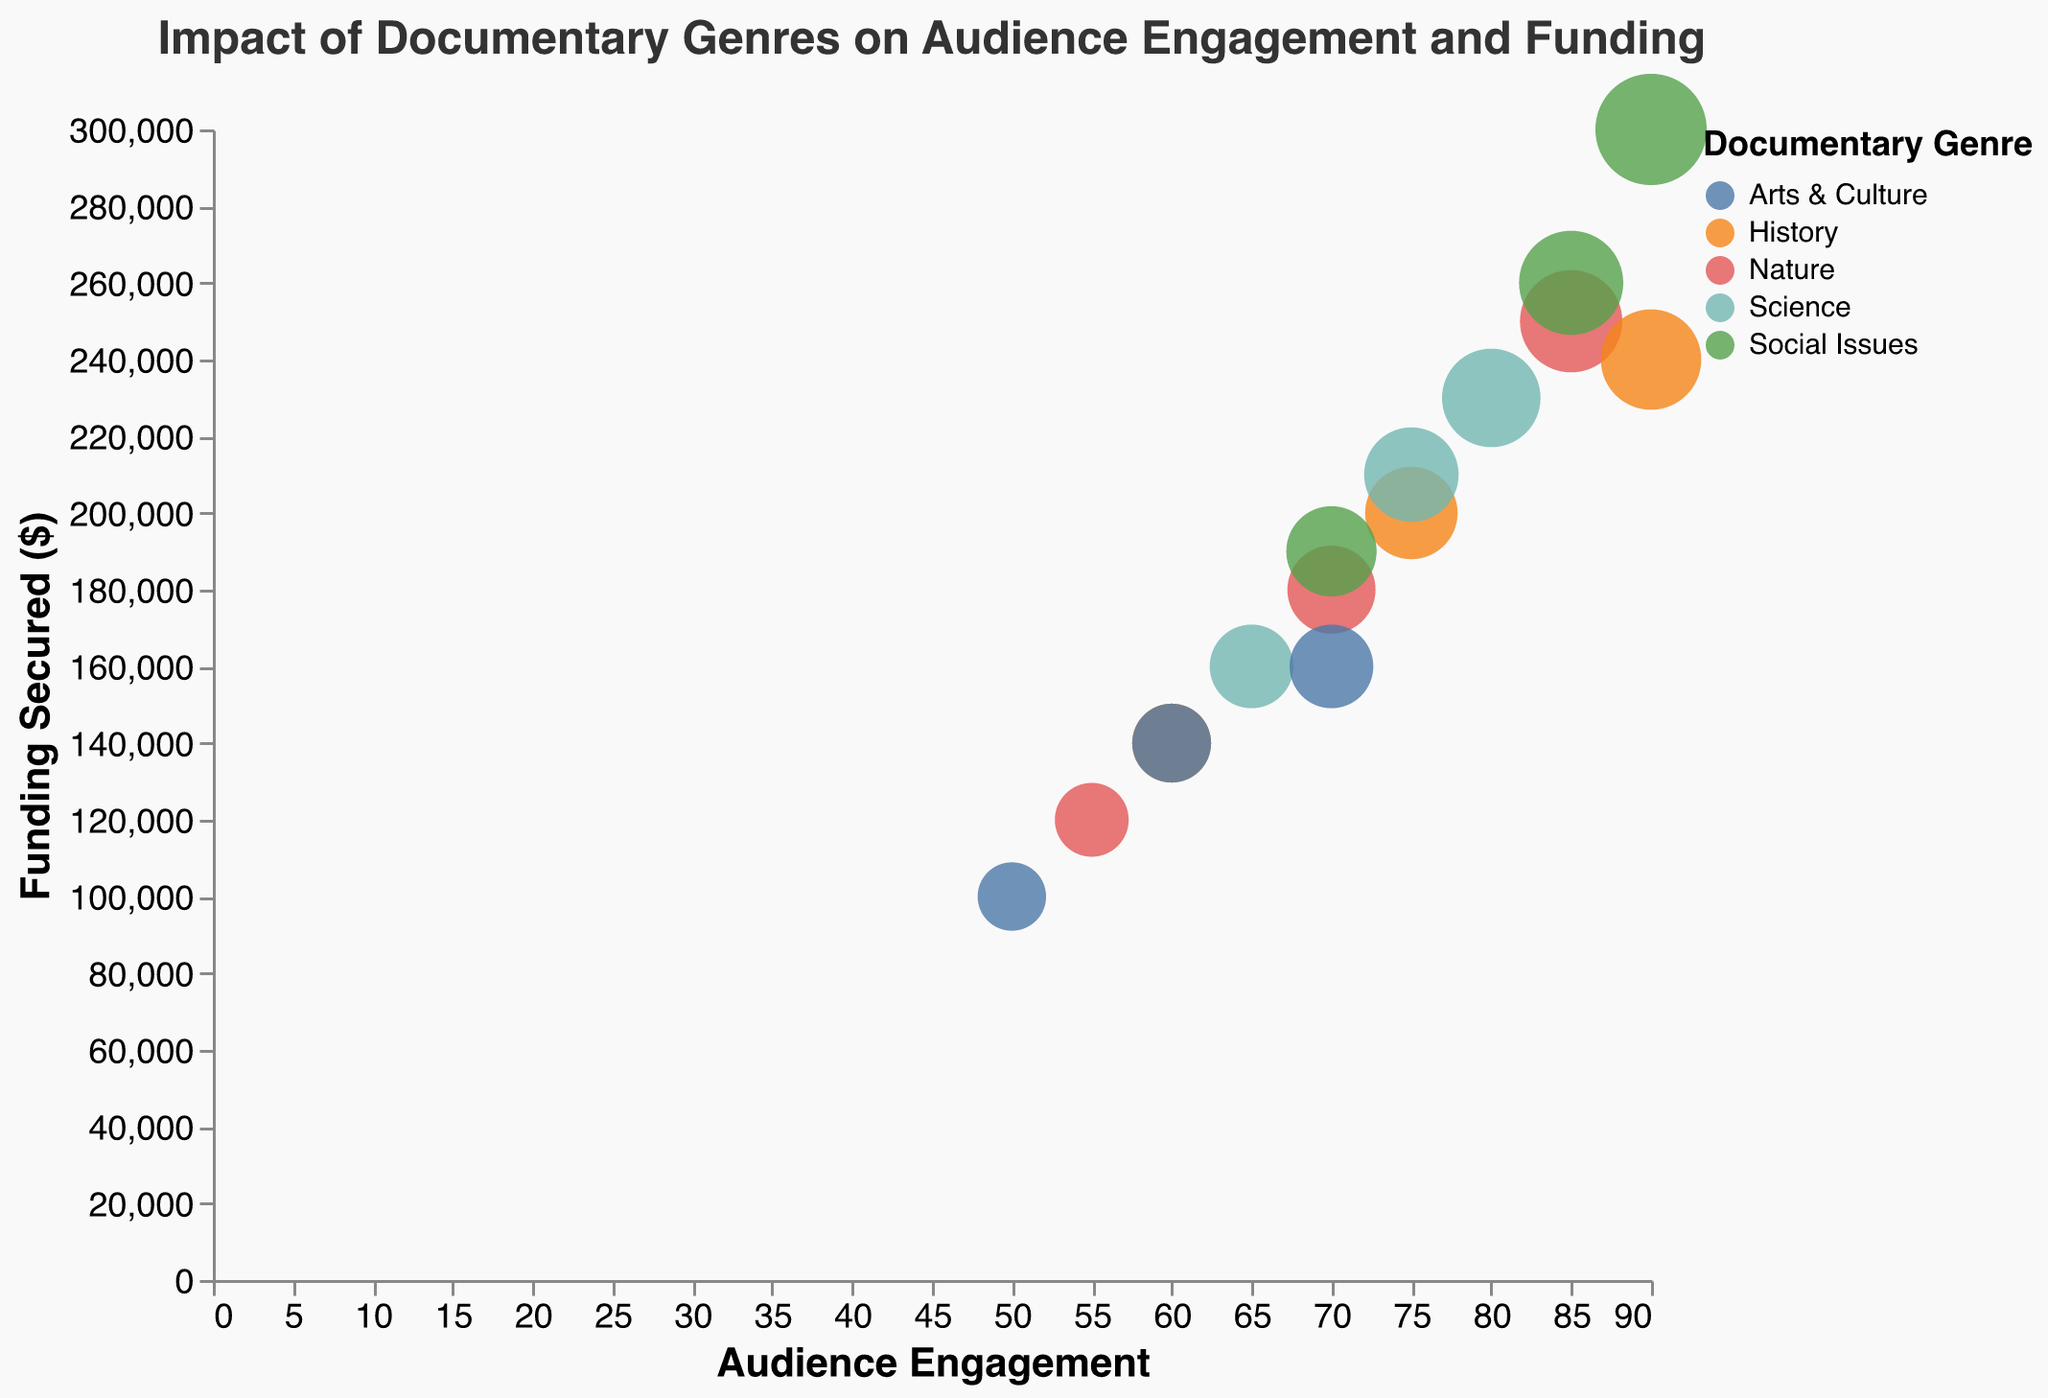What is the title of the chart? The title is shown at the top of the figure. It reads "Impact of Documentary Genres on Audience Engagement and Funding".
Answer: Impact of Documentary Genres on Audience Engagement and Funding Which geographic region appears to have the highest audience engagement for Social Issues documentaries? From the figure, Social Issues documentaries are marked by their unique shape and color, and the North America region bubble is at the highest position on the Audience Engagement axis.
Answer: North America What is the average audience engagement for the Nature genre across all geographic regions? The audience engagement values for the Nature genre are 85 (North America), 70 (Europe), and 55 (Asia). The average is calculated as (85 + 70 + 55) / 3.
Answer: 70 For which genre and geographic region does the bubble with the greatest size occur? The largest bubbles can be identified by their size alone. Comparing the sizes tied to funding, the maximum size corresponds to Social Issues in North America, indicating highest funding secured.
Answer: Social Issues, North America Which genre has the lowest audience engagement in Asia? By referring to the Asia region’s data points along the Audience Engagement axis, the lowest value is seen in the Arts & Culture genre (50).
Answer: Arts & Culture Between History and Science genres in Europe, which one secures more funding? We look at the bubbles for History and Science in Europe. The History genre secures $240,000, while Science secures $210,000.
Answer: History What is the total funding secured for Arts & Culture documentaries across all geographic regions? The funding secured for Arts & Culture in North America is $160,000, Europe is $140,000, and Asia is $100,000. Summing these values gives the total funding.
Answer: $400,000 Which geographic region has the lowest audience engagement for any genre? Observing the lowest positions for audience engagement across the regions, the Asia region for Arts & Culture has the lowest engagement value of 50.
Answer: Asia What is the difference in audience engagement between Social Issues in Europe and Arts & Culture in North America? The audience engagement for Social Issues in Europe is 85, and for Arts & Culture in North America, it is 70. The difference is calculated as 85 - 70.
Answer: 15 Which genre has the most consistent audience engagement across geographic regions? The consistency can be inferred by observing the variance in audience engagement values across regions for each genre. The Science genre shows minimal variation: North America (80), Europe (75), and Asia (65).
Answer: Science 